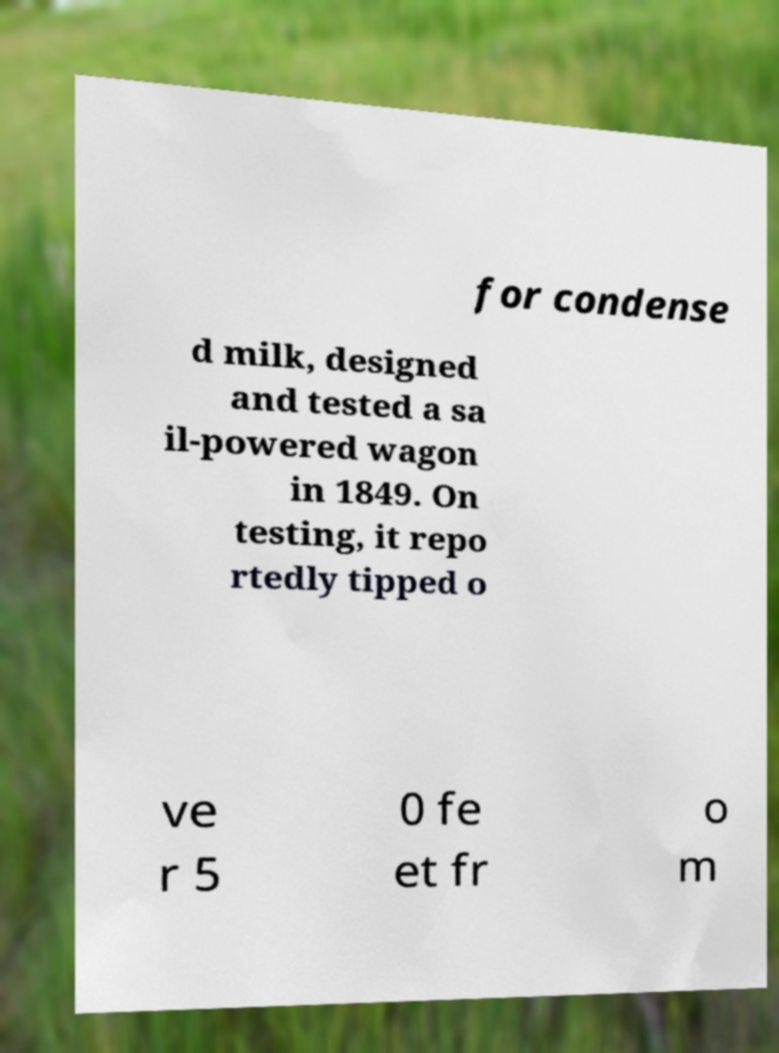There's text embedded in this image that I need extracted. Can you transcribe it verbatim? for condense d milk, designed and tested a sa il-powered wagon in 1849. On testing, it repo rtedly tipped o ve r 5 0 fe et fr o m 